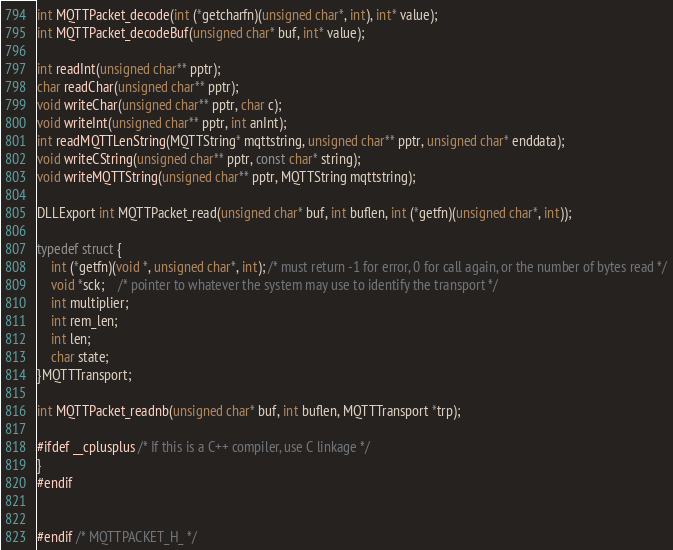Convert code to text. <code><loc_0><loc_0><loc_500><loc_500><_C_>int MQTTPacket_decode(int (*getcharfn)(unsigned char*, int), int* value);
int MQTTPacket_decodeBuf(unsigned char* buf, int* value);

int readInt(unsigned char** pptr);
char readChar(unsigned char** pptr);
void writeChar(unsigned char** pptr, char c);
void writeInt(unsigned char** pptr, int anInt);
int readMQTTLenString(MQTTString* mqttstring, unsigned char** pptr, unsigned char* enddata);
void writeCString(unsigned char** pptr, const char* string);
void writeMQTTString(unsigned char** pptr, MQTTString mqttstring);

DLLExport int MQTTPacket_read(unsigned char* buf, int buflen, int (*getfn)(unsigned char*, int));

typedef struct {
	int (*getfn)(void *, unsigned char*, int); /* must return -1 for error, 0 for call again, or the number of bytes read */
	void *sck;	/* pointer to whatever the system may use to identify the transport */
	int multiplier;
	int rem_len;
	int len;
	char state;
}MQTTTransport;

int MQTTPacket_readnb(unsigned char* buf, int buflen, MQTTTransport *trp);

#ifdef __cplusplus /* If this is a C++ compiler, use C linkage */
}
#endif


#endif /* MQTTPACKET_H_ */
</code> 